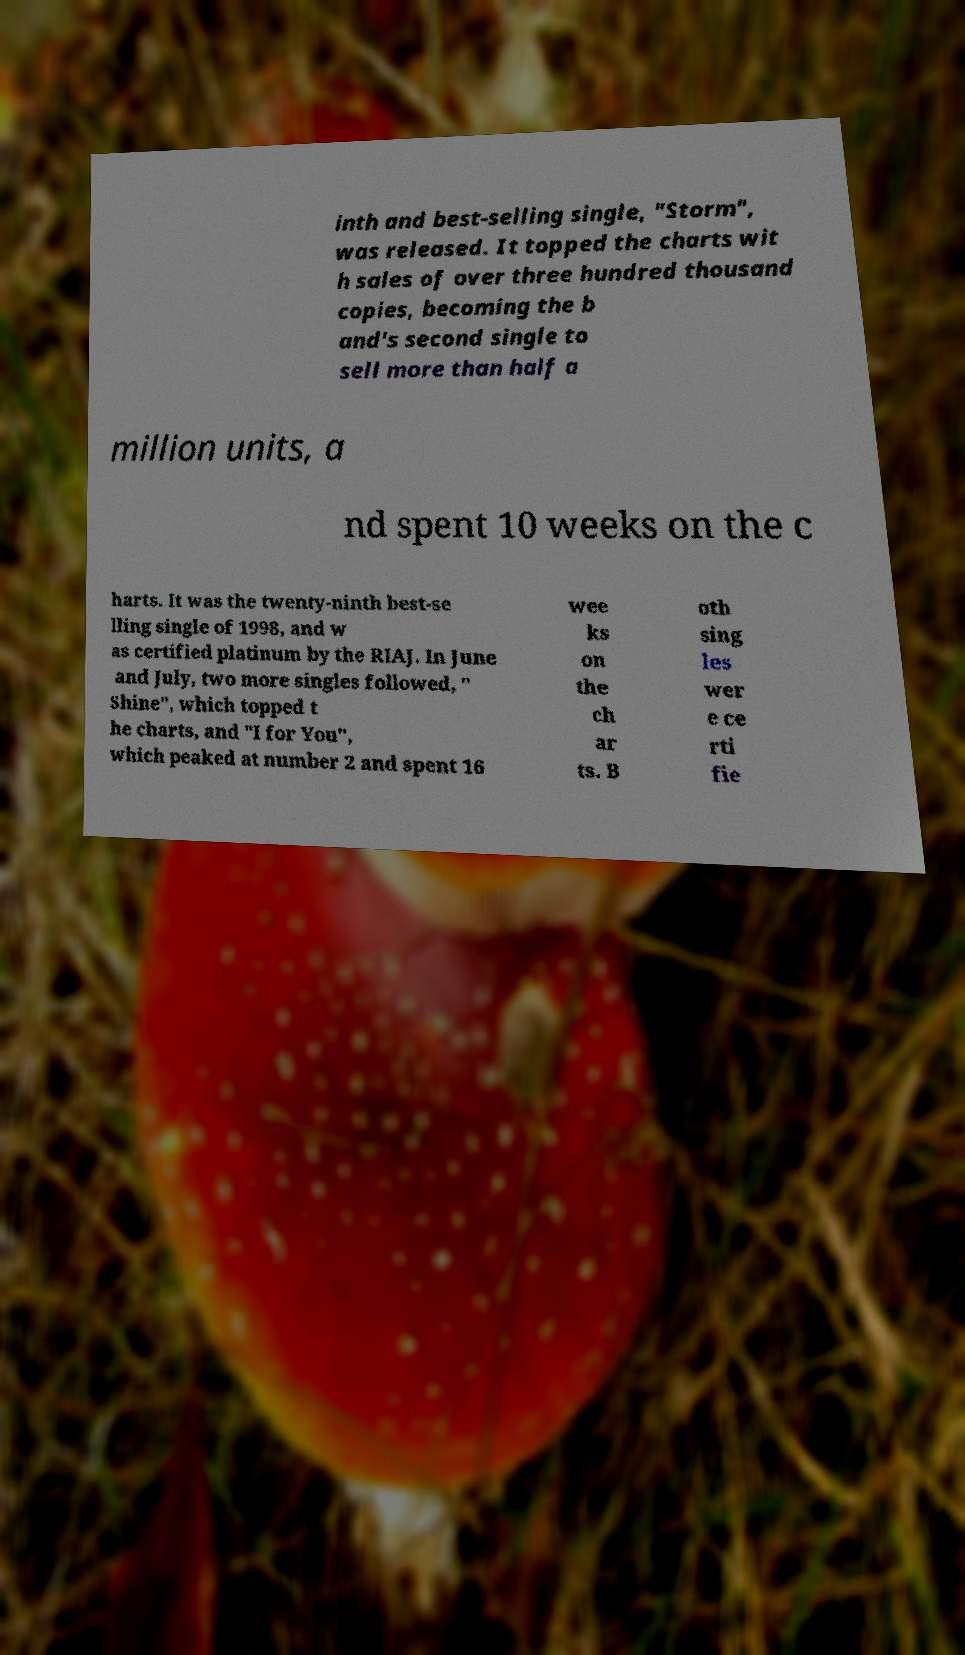Could you extract and type out the text from this image? inth and best-selling single, "Storm", was released. It topped the charts wit h sales of over three hundred thousand copies, becoming the b and's second single to sell more than half a million units, a nd spent 10 weeks on the c harts. It was the twenty-ninth best-se lling single of 1998, and w as certified platinum by the RIAJ. In June and July, two more singles followed, " Shine", which topped t he charts, and "I for You", which peaked at number 2 and spent 16 wee ks on the ch ar ts. B oth sing les wer e ce rti fie 